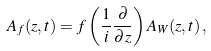Convert formula to latex. <formula><loc_0><loc_0><loc_500><loc_500>A _ { f } ( z , t ) = f \left ( \frac { 1 } { i } \frac { \partial } { \partial z } \right ) A _ { W } ( z , t ) \, ,</formula> 